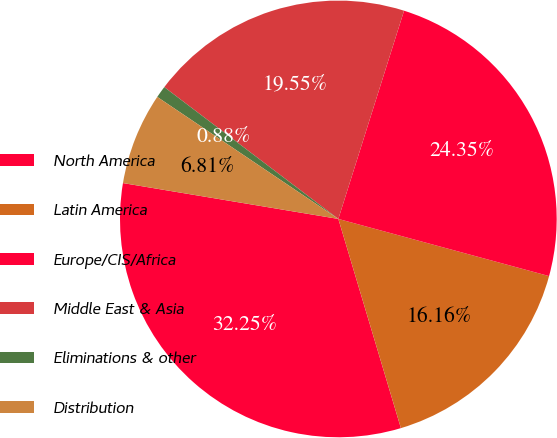<chart> <loc_0><loc_0><loc_500><loc_500><pie_chart><fcel>North America<fcel>Latin America<fcel>Europe/CIS/Africa<fcel>Middle East & Asia<fcel>Eliminations & other<fcel>Distribution<nl><fcel>32.25%<fcel>16.16%<fcel>24.35%<fcel>19.55%<fcel>0.88%<fcel>6.81%<nl></chart> 